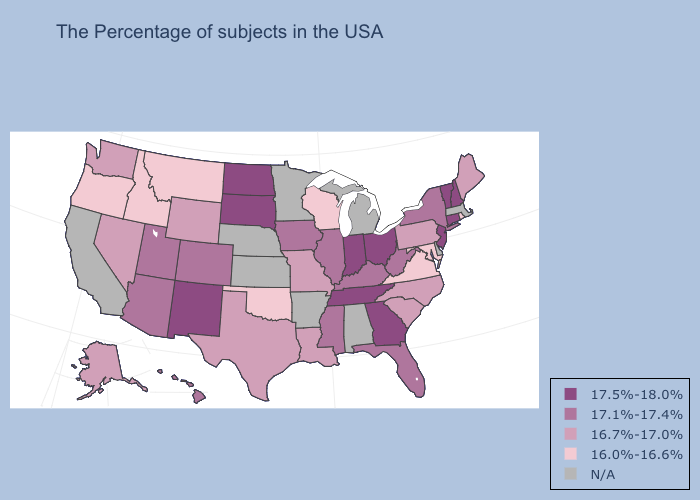What is the lowest value in states that border Utah?
Give a very brief answer. 16.0%-16.6%. What is the value of Illinois?
Concise answer only. 17.1%-17.4%. Does Vermont have the lowest value in the Northeast?
Concise answer only. No. Does New Mexico have the highest value in the West?
Quick response, please. Yes. Among the states that border Montana , does North Dakota have the lowest value?
Keep it brief. No. What is the highest value in states that border Nevada?
Keep it brief. 17.1%-17.4%. Among the states that border California , which have the lowest value?
Give a very brief answer. Oregon. Does Louisiana have the highest value in the USA?
Short answer required. No. What is the highest value in states that border Maine?
Write a very short answer. 17.5%-18.0%. Which states have the lowest value in the MidWest?
Quick response, please. Wisconsin. Name the states that have a value in the range 17.5%-18.0%?
Write a very short answer. New Hampshire, Vermont, Connecticut, New Jersey, Ohio, Georgia, Indiana, Tennessee, South Dakota, North Dakota, New Mexico. Is the legend a continuous bar?
Keep it brief. No. Does Louisiana have the highest value in the USA?
Keep it brief. No. What is the lowest value in the USA?
Short answer required. 16.0%-16.6%. 